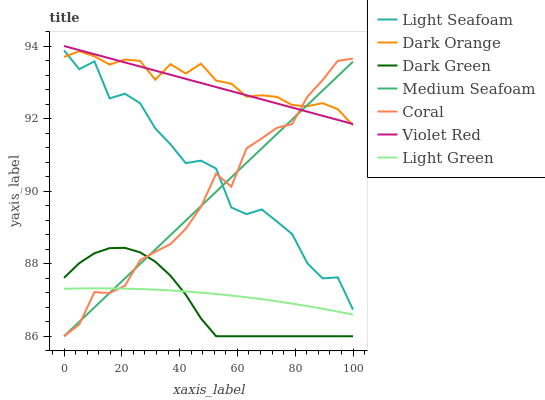Does Dark Green have the minimum area under the curve?
Answer yes or no. Yes. Does Dark Orange have the maximum area under the curve?
Answer yes or no. Yes. Does Violet Red have the minimum area under the curve?
Answer yes or no. No. Does Violet Red have the maximum area under the curve?
Answer yes or no. No. Is Medium Seafoam the smoothest?
Answer yes or no. Yes. Is Light Seafoam the roughest?
Answer yes or no. Yes. Is Violet Red the smoothest?
Answer yes or no. No. Is Violet Red the roughest?
Answer yes or no. No. Does Coral have the lowest value?
Answer yes or no. Yes. Does Violet Red have the lowest value?
Answer yes or no. No. Does Violet Red have the highest value?
Answer yes or no. Yes. Does Coral have the highest value?
Answer yes or no. No. Is Light Seafoam less than Violet Red?
Answer yes or no. Yes. Is Dark Orange greater than Light Green?
Answer yes or no. Yes. Does Medium Seafoam intersect Violet Red?
Answer yes or no. Yes. Is Medium Seafoam less than Violet Red?
Answer yes or no. No. Is Medium Seafoam greater than Violet Red?
Answer yes or no. No. Does Light Seafoam intersect Violet Red?
Answer yes or no. No. 